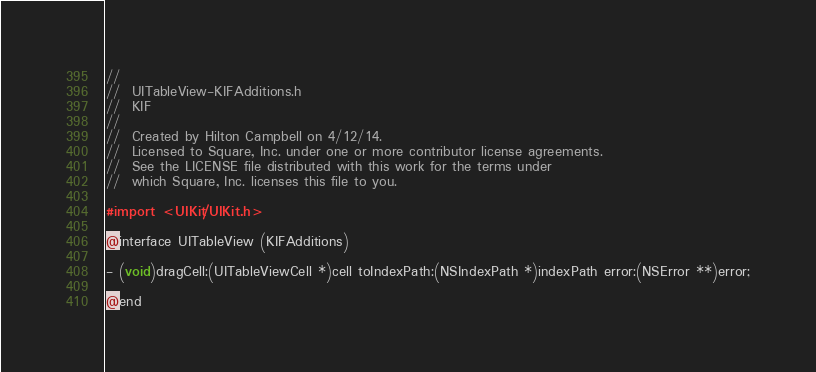Convert code to text. <code><loc_0><loc_0><loc_500><loc_500><_C_>//
//  UITableView-KIFAdditions.h
//  KIF
//
//  Created by Hilton Campbell on 4/12/14.
//  Licensed to Square, Inc. under one or more contributor license agreements.
//  See the LICENSE file distributed with this work for the terms under
//  which Square, Inc. licenses this file to you.

#import <UIKit/UIKit.h>

@interface UITableView (KIFAdditions)

- (void)dragCell:(UITableViewCell *)cell toIndexPath:(NSIndexPath *)indexPath error:(NSError **)error;

@end
</code> 